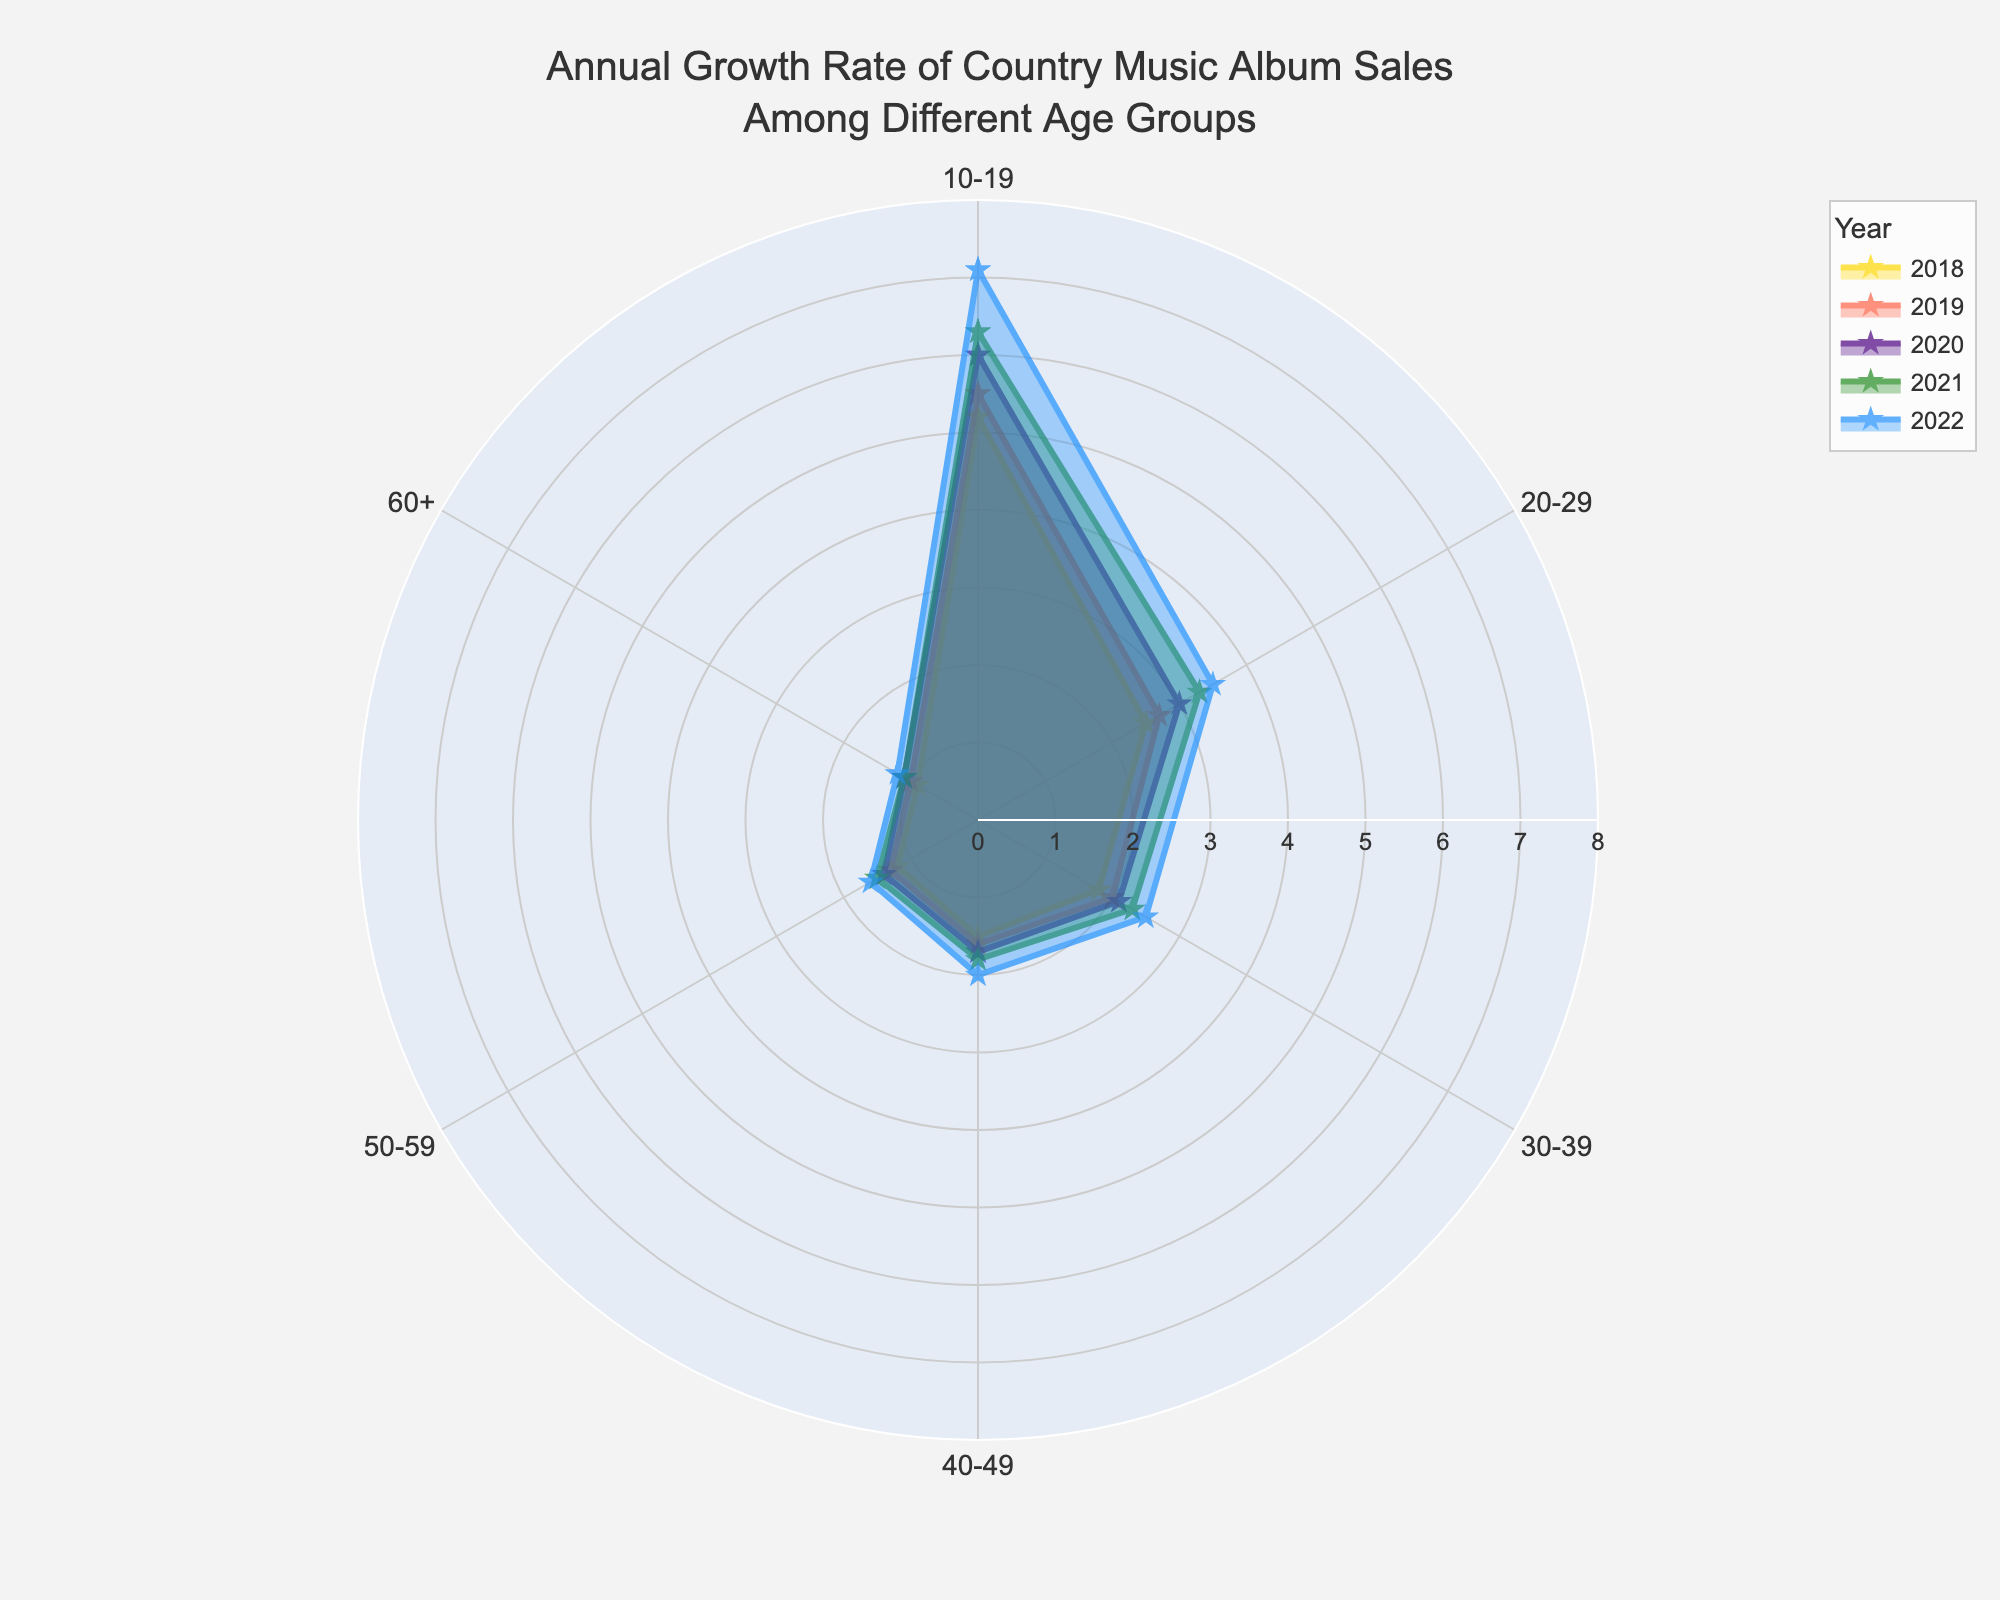what is the highest growth rate shown for the age group 10-19? To determine the highest growth rate for the age group 10-19, examine the values in the figure. The highest value appears in 2022.
Answer: 7.1 what is the average growth rate for the age group 30-39 over the 5-year period? Add all the growth rate values for the age group 30-39 from 2018 to 2022 and then divide by the number of years (5). So the calculation is (1.8 + 2.0 + 2.1 + 2.3 + 2.5) / 5 = 10.7 / 5 = 2.14
Answer: 2.14 Which age group had the lowest growth rate in 2018? Compare the growth rates of all age groups for the year 2018. The age group 60+ has the lowest rate at 0.9.
Answer: 60+ How much did the growth rate for the age group 20-29 increase from 2018 to 2022? Subtract the growth rate in 2018 from the growth rate in 2022 for the age group 20-29. The calculation is 3.5 - 2.5 = 1.0
Answer: 1.0 In which year did the age group 40-49 experience the highest growth rate? Examine the growth rates for the age group 40-49 across the years. The highest growth rate is in the year 2022 with a value of 2.0.
Answer: 2022 Which year shows the highest growth rate for the majority of age groups? Compare the highest growth rates across different years for each age group. The year 2022 shows the highest growth rate for most age groups.
Answer: 2022 What is the total growth rate for the age group 50-59 from 2018 to 2022? Sum up the growth rates for the age group 50-59 from 2018 to 2022. The calculation is 1.2 + 1.3 + 1.4 + 1.5 + 1.6 = 7.0
Answer: 7.0 What are the age groups represented in the chart? Identify all the age groups mentioned along the theta axis of the radar chart. The age groups are 10-19, 20-29, 30-39, 40-49, 50-59, and 60+.
Answer: 10-19, 20-29, 30-39, 40-49, 50-59, 60+ By how much did the growth rate for the age group 60+ change from 2019 to 2020? Subtract the growth rate in 2019 from the growth rate in 2020 for the age group 60+. The calculation is 1.1 - 1.0 = 0.1
Answer: 0.1 